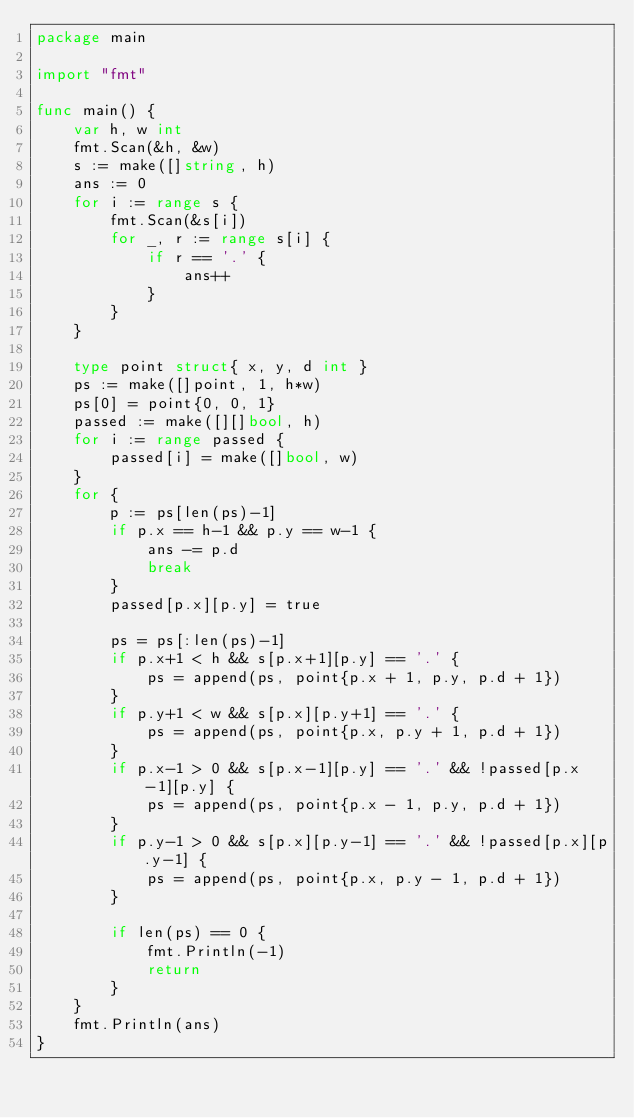Convert code to text. <code><loc_0><loc_0><loc_500><loc_500><_Go_>package main

import "fmt"

func main() {
	var h, w int
	fmt.Scan(&h, &w)
	s := make([]string, h)
	ans := 0
	for i := range s {
		fmt.Scan(&s[i])
		for _, r := range s[i] {
			if r == '.' {
				ans++
			}
		}
	}

	type point struct{ x, y, d int }
	ps := make([]point, 1, h*w)
	ps[0] = point{0, 0, 1}
	passed := make([][]bool, h)
	for i := range passed {
		passed[i] = make([]bool, w)
	}
	for {
		p := ps[len(ps)-1]
		if p.x == h-1 && p.y == w-1 {
			ans -= p.d
			break
		}
		passed[p.x][p.y] = true

		ps = ps[:len(ps)-1]
		if p.x+1 < h && s[p.x+1][p.y] == '.' {
			ps = append(ps, point{p.x + 1, p.y, p.d + 1})
		}
		if p.y+1 < w && s[p.x][p.y+1] == '.' {
			ps = append(ps, point{p.x, p.y + 1, p.d + 1})
		}
		if p.x-1 > 0 && s[p.x-1][p.y] == '.' && !passed[p.x-1][p.y] {
			ps = append(ps, point{p.x - 1, p.y, p.d + 1})
		}
		if p.y-1 > 0 && s[p.x][p.y-1] == '.' && !passed[p.x][p.y-1] {
			ps = append(ps, point{p.x, p.y - 1, p.d + 1})
		}

		if len(ps) == 0 {
			fmt.Println(-1)
			return
		}
	}
	fmt.Println(ans)
}
</code> 